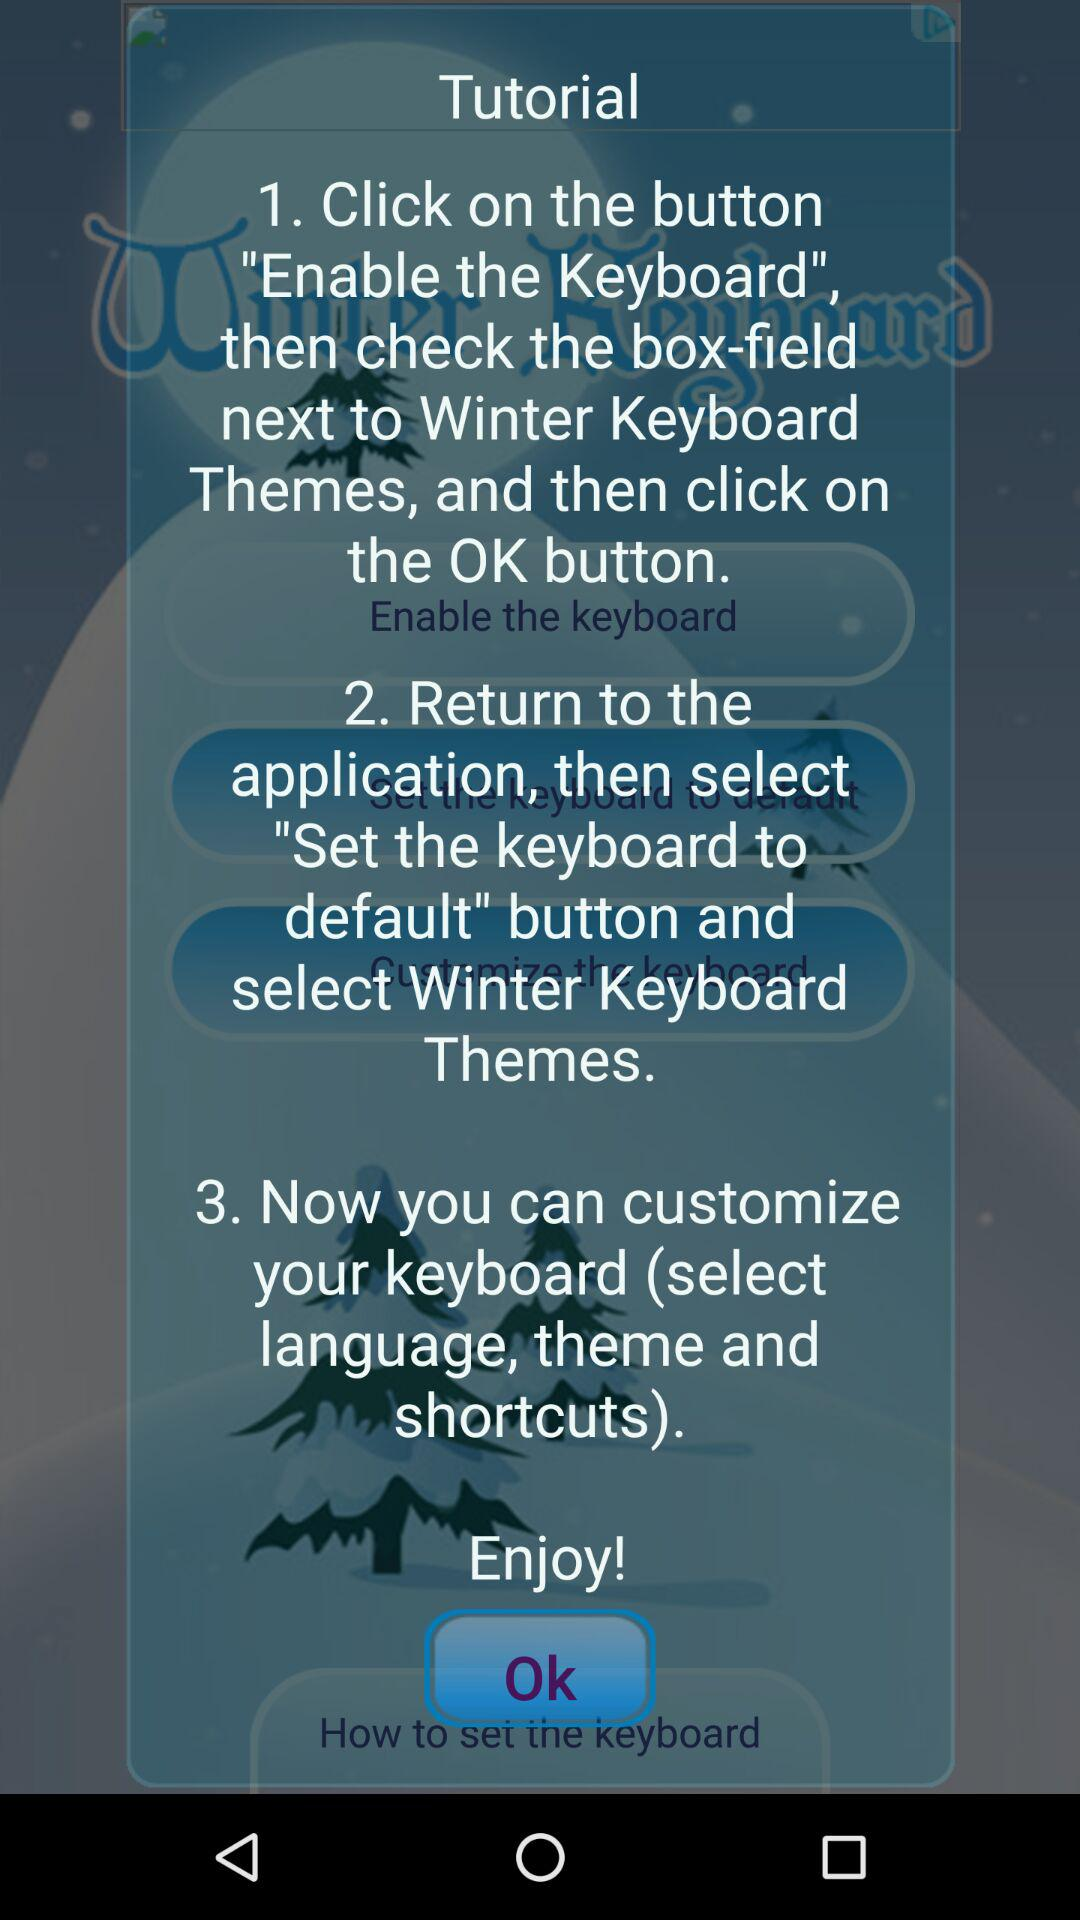What is the name of the application? The name of the application is "Winter Keyboard". 